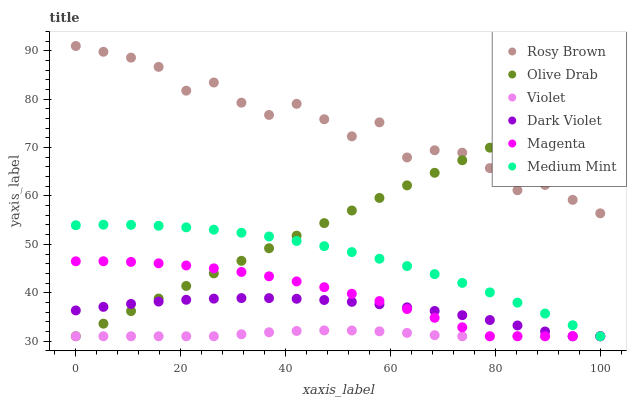Does Violet have the minimum area under the curve?
Answer yes or no. Yes. Does Rosy Brown have the maximum area under the curve?
Answer yes or no. Yes. Does Dark Violet have the minimum area under the curve?
Answer yes or no. No. Does Dark Violet have the maximum area under the curve?
Answer yes or no. No. Is Olive Drab the smoothest?
Answer yes or no. Yes. Is Rosy Brown the roughest?
Answer yes or no. Yes. Is Dark Violet the smoothest?
Answer yes or no. No. Is Dark Violet the roughest?
Answer yes or no. No. Does Medium Mint have the lowest value?
Answer yes or no. Yes. Does Rosy Brown have the lowest value?
Answer yes or no. No. Does Rosy Brown have the highest value?
Answer yes or no. Yes. Does Dark Violet have the highest value?
Answer yes or no. No. Is Violet less than Rosy Brown?
Answer yes or no. Yes. Is Rosy Brown greater than Medium Mint?
Answer yes or no. Yes. Does Dark Violet intersect Magenta?
Answer yes or no. Yes. Is Dark Violet less than Magenta?
Answer yes or no. No. Is Dark Violet greater than Magenta?
Answer yes or no. No. Does Violet intersect Rosy Brown?
Answer yes or no. No. 